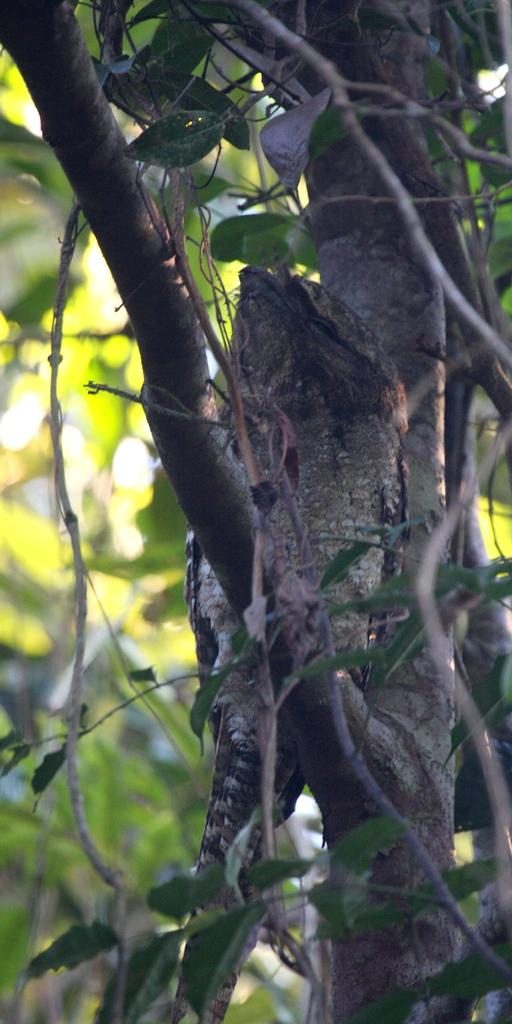What type of animal is in the image? There is a bird in the image. Where is the bird located? The bird is standing on a branch of a tree. What can be seen in the background of the image? There are many plants in the background of the image. What type of mind can be seen in the image? There is no mind present in the image; it features a bird standing on a branch of a tree. Can you tell me how many mint leaves are visible in the image? There is no mint present in the image. 